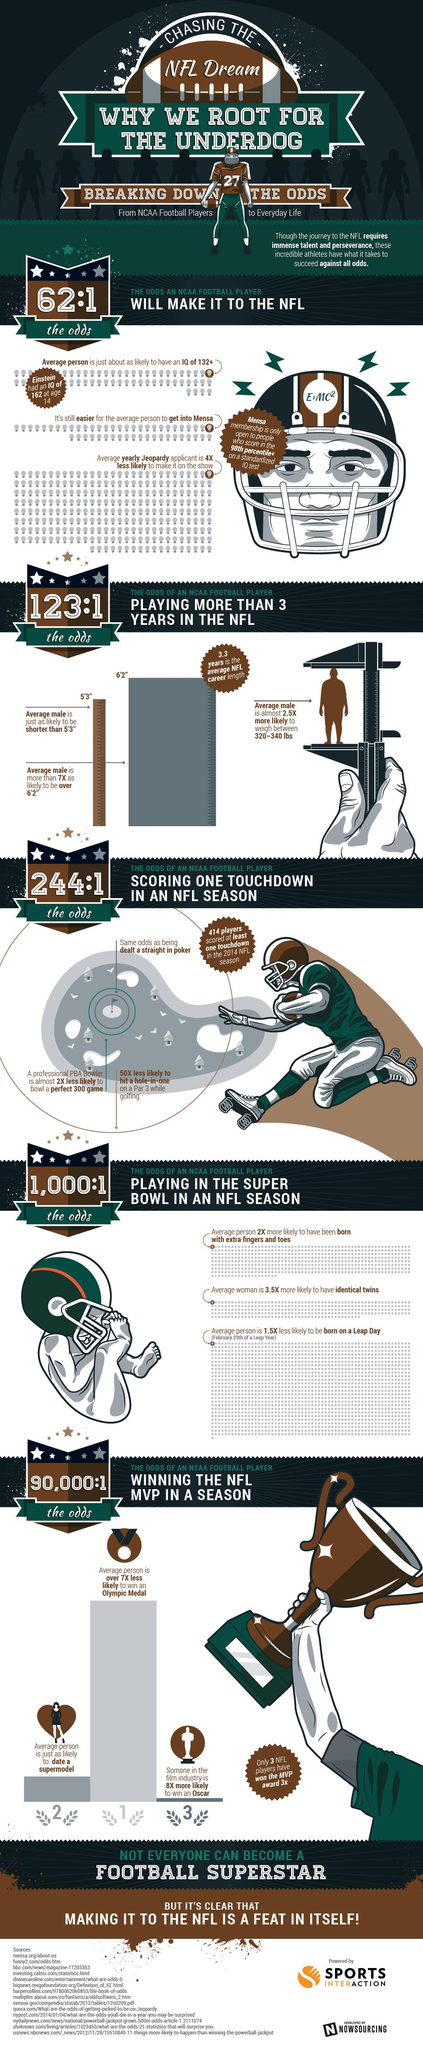Specify some key components in this picture. Who has won the MVP award three times? The answer is three people: [Name 1], [Name 2], and [Name 3]. 